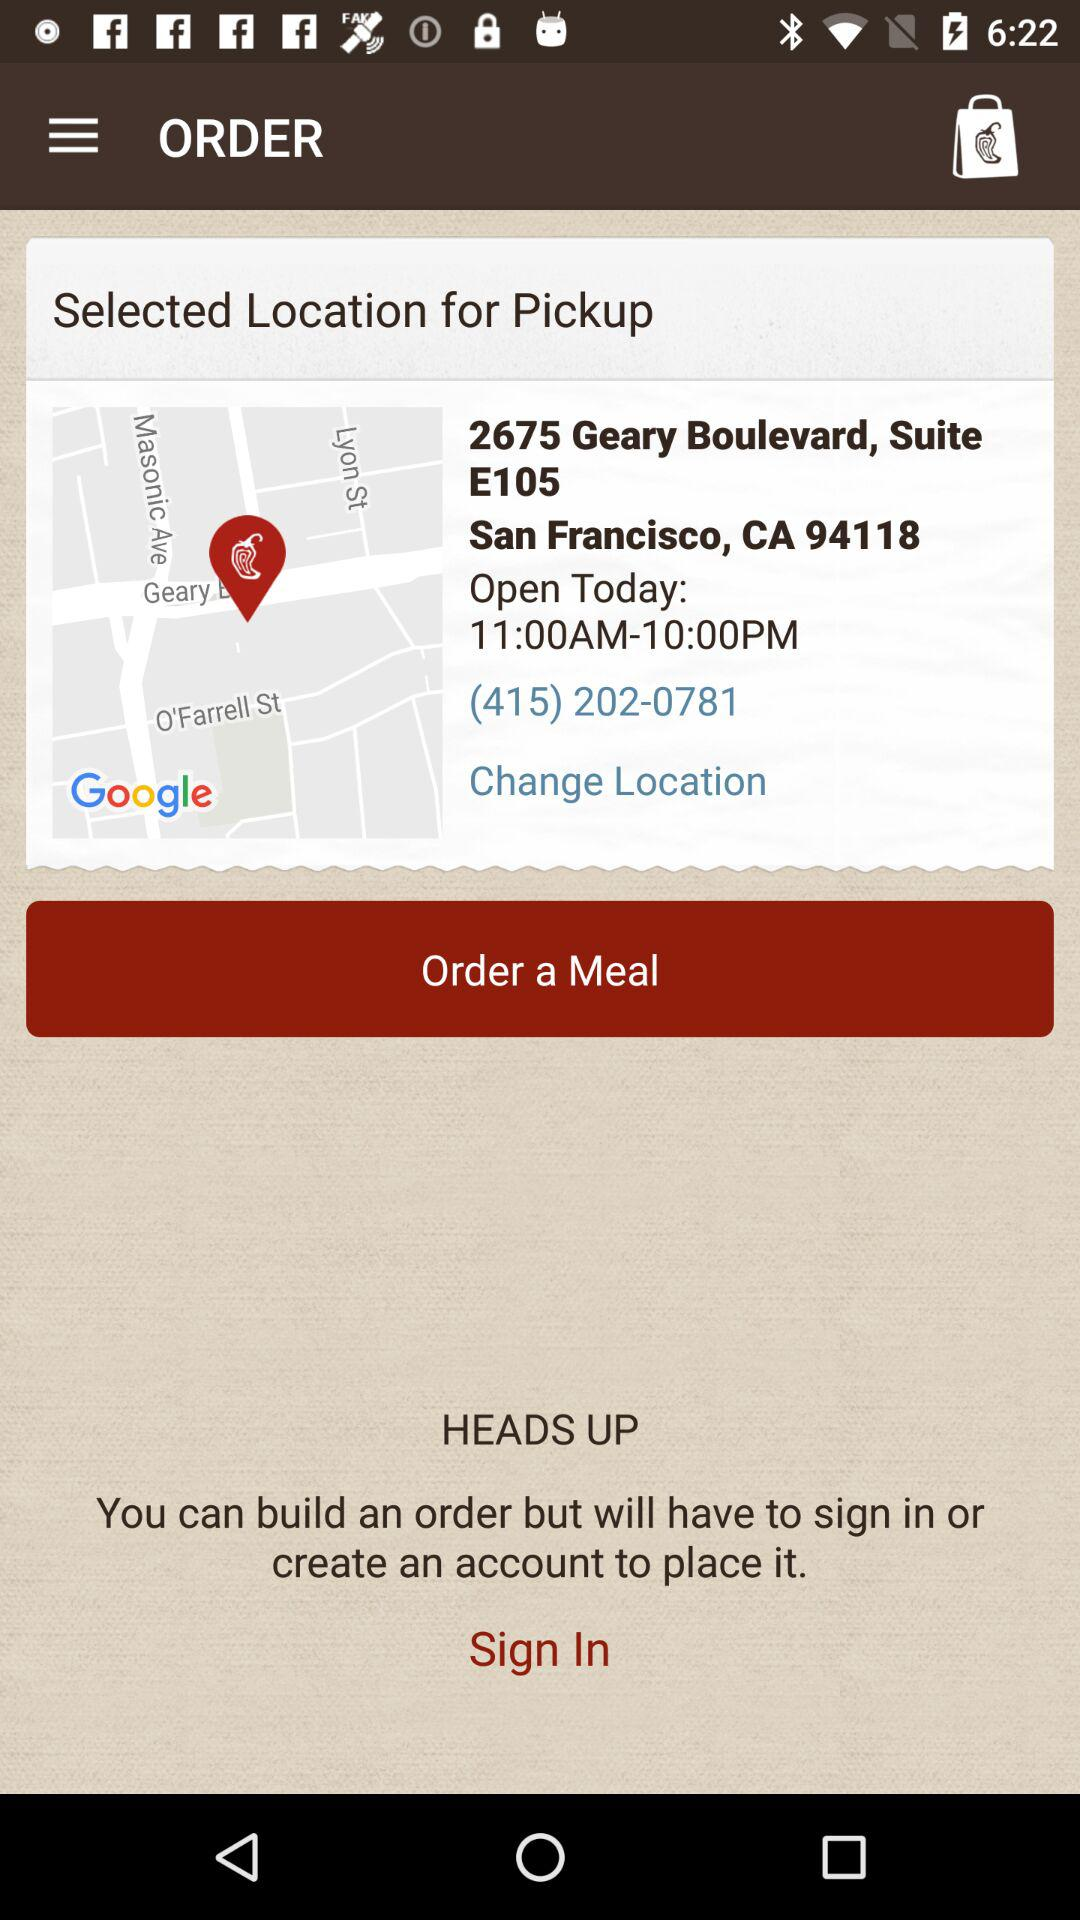What is the phone number of the restaurant?
Answer the question using a single word or phrase. (415) 202-0781 